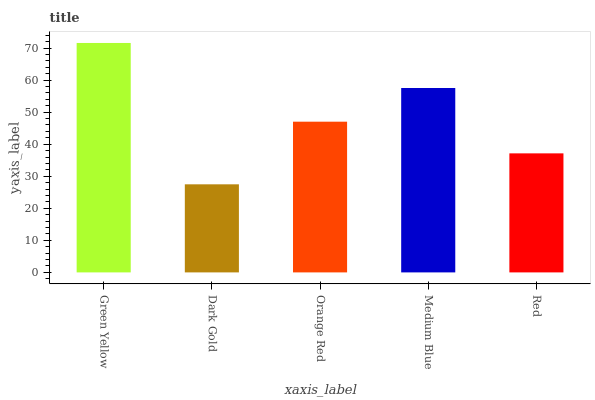Is Dark Gold the minimum?
Answer yes or no. Yes. Is Green Yellow the maximum?
Answer yes or no. Yes. Is Orange Red the minimum?
Answer yes or no. No. Is Orange Red the maximum?
Answer yes or no. No. Is Orange Red greater than Dark Gold?
Answer yes or no. Yes. Is Dark Gold less than Orange Red?
Answer yes or no. Yes. Is Dark Gold greater than Orange Red?
Answer yes or no. No. Is Orange Red less than Dark Gold?
Answer yes or no. No. Is Orange Red the high median?
Answer yes or no. Yes. Is Orange Red the low median?
Answer yes or no. Yes. Is Green Yellow the high median?
Answer yes or no. No. Is Medium Blue the low median?
Answer yes or no. No. 